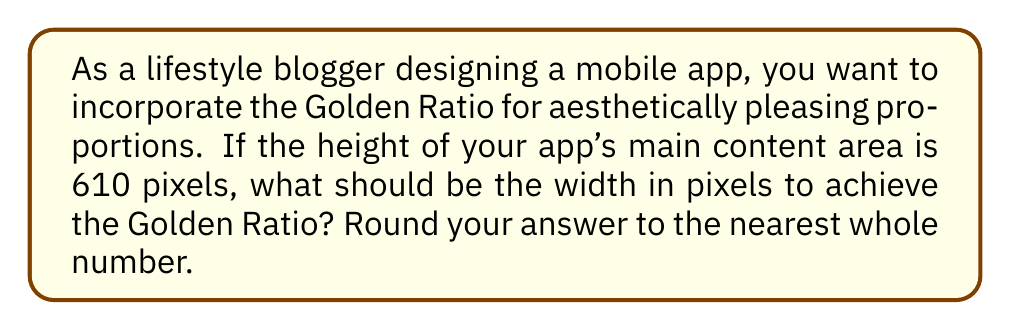Can you solve this math problem? Let's approach this step-by-step:

1. The Golden Ratio, denoted by φ (phi), is approximately 1.618033988749895.

2. The Golden Ratio is defined as:

   $$\phi = \frac{a+b}{a} = \frac{a}{b}$$

   where $a$ is the longer segment and $b$ is the shorter segment.

3. In our case, the height (610 pixels) represents the longer segment $a$, and we need to find the width $b$.

4. We can set up the equation:

   $$\phi = \frac{610}{b}$$

5. Substituting the value of φ:

   $$1.618033988749895 = \frac{610}{b}$$

6. Solving for $b$:

   $$b = \frac{610}{1.618033988749895}$$

7. Calculate:

   $$b ≈ 376.9911184307752$$

8. Rounding to the nearest whole number:

   $$b ≈ 377$$

Therefore, the width of the app's main content area should be 377 pixels to achieve the Golden Ratio with a height of 610 pixels.
Answer: 377 pixels 